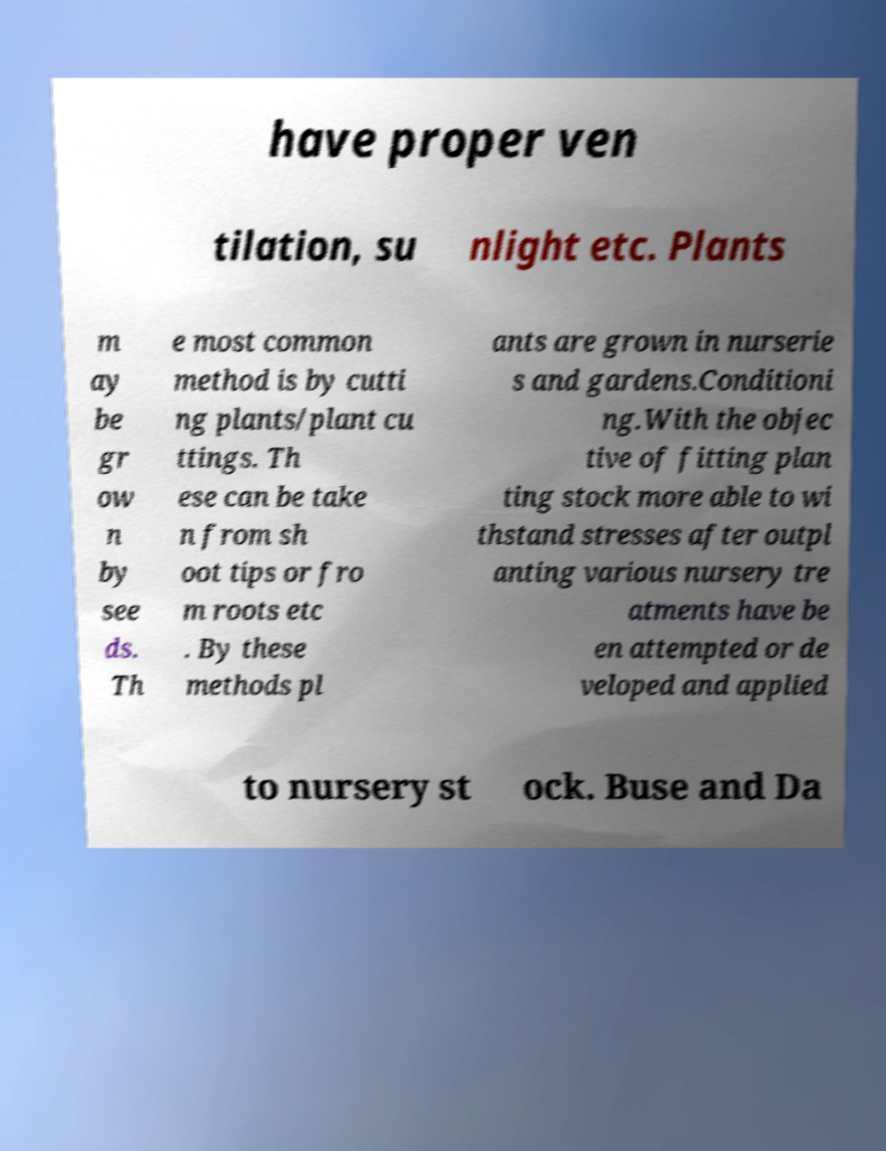Can you read and provide the text displayed in the image?This photo seems to have some interesting text. Can you extract and type it out for me? have proper ven tilation, su nlight etc. Plants m ay be gr ow n by see ds. Th e most common method is by cutti ng plants/plant cu ttings. Th ese can be take n from sh oot tips or fro m roots etc . By these methods pl ants are grown in nurserie s and gardens.Conditioni ng.With the objec tive of fitting plan ting stock more able to wi thstand stresses after outpl anting various nursery tre atments have be en attempted or de veloped and applied to nursery st ock. Buse and Da 